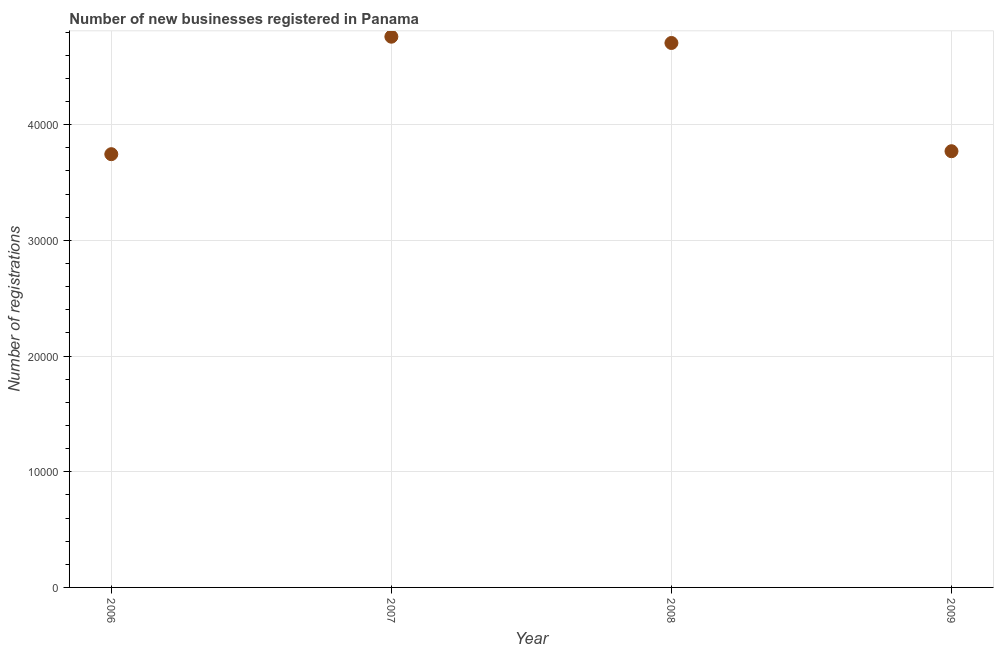What is the number of new business registrations in 2009?
Offer a terse response. 3.77e+04. Across all years, what is the maximum number of new business registrations?
Ensure brevity in your answer.  4.76e+04. Across all years, what is the minimum number of new business registrations?
Your response must be concise. 3.75e+04. In which year was the number of new business registrations maximum?
Your answer should be very brief. 2007. What is the sum of the number of new business registrations?
Provide a succinct answer. 1.70e+05. What is the difference between the number of new business registrations in 2007 and 2008?
Your answer should be very brief. 543. What is the average number of new business registrations per year?
Offer a terse response. 4.25e+04. What is the median number of new business registrations?
Provide a succinct answer. 4.24e+04. What is the ratio of the number of new business registrations in 2007 to that in 2008?
Your answer should be very brief. 1.01. Is the number of new business registrations in 2007 less than that in 2008?
Offer a very short reply. No. Is the difference between the number of new business registrations in 2006 and 2007 greater than the difference between any two years?
Your response must be concise. Yes. What is the difference between the highest and the second highest number of new business registrations?
Offer a very short reply. 543. What is the difference between the highest and the lowest number of new business registrations?
Provide a short and direct response. 1.02e+04. In how many years, is the number of new business registrations greater than the average number of new business registrations taken over all years?
Your answer should be compact. 2. Does the number of new business registrations monotonically increase over the years?
Offer a terse response. No. How many dotlines are there?
Offer a terse response. 1. How many years are there in the graph?
Give a very brief answer. 4. What is the difference between two consecutive major ticks on the Y-axis?
Provide a succinct answer. 10000. Are the values on the major ticks of Y-axis written in scientific E-notation?
Make the answer very short. No. Does the graph contain grids?
Offer a very short reply. Yes. What is the title of the graph?
Provide a succinct answer. Number of new businesses registered in Panama. What is the label or title of the Y-axis?
Your response must be concise. Number of registrations. What is the Number of registrations in 2006?
Make the answer very short. 3.75e+04. What is the Number of registrations in 2007?
Keep it short and to the point. 4.76e+04. What is the Number of registrations in 2008?
Your response must be concise. 4.71e+04. What is the Number of registrations in 2009?
Your answer should be compact. 3.77e+04. What is the difference between the Number of registrations in 2006 and 2007?
Offer a very short reply. -1.02e+04. What is the difference between the Number of registrations in 2006 and 2008?
Give a very brief answer. -9613. What is the difference between the Number of registrations in 2006 and 2009?
Ensure brevity in your answer.  -256. What is the difference between the Number of registrations in 2007 and 2008?
Offer a very short reply. 543. What is the difference between the Number of registrations in 2007 and 2009?
Keep it short and to the point. 9900. What is the difference between the Number of registrations in 2008 and 2009?
Make the answer very short. 9357. What is the ratio of the Number of registrations in 2006 to that in 2007?
Keep it short and to the point. 0.79. What is the ratio of the Number of registrations in 2006 to that in 2008?
Keep it short and to the point. 0.8. What is the ratio of the Number of registrations in 2006 to that in 2009?
Provide a short and direct response. 0.99. What is the ratio of the Number of registrations in 2007 to that in 2009?
Your response must be concise. 1.26. What is the ratio of the Number of registrations in 2008 to that in 2009?
Give a very brief answer. 1.25. 